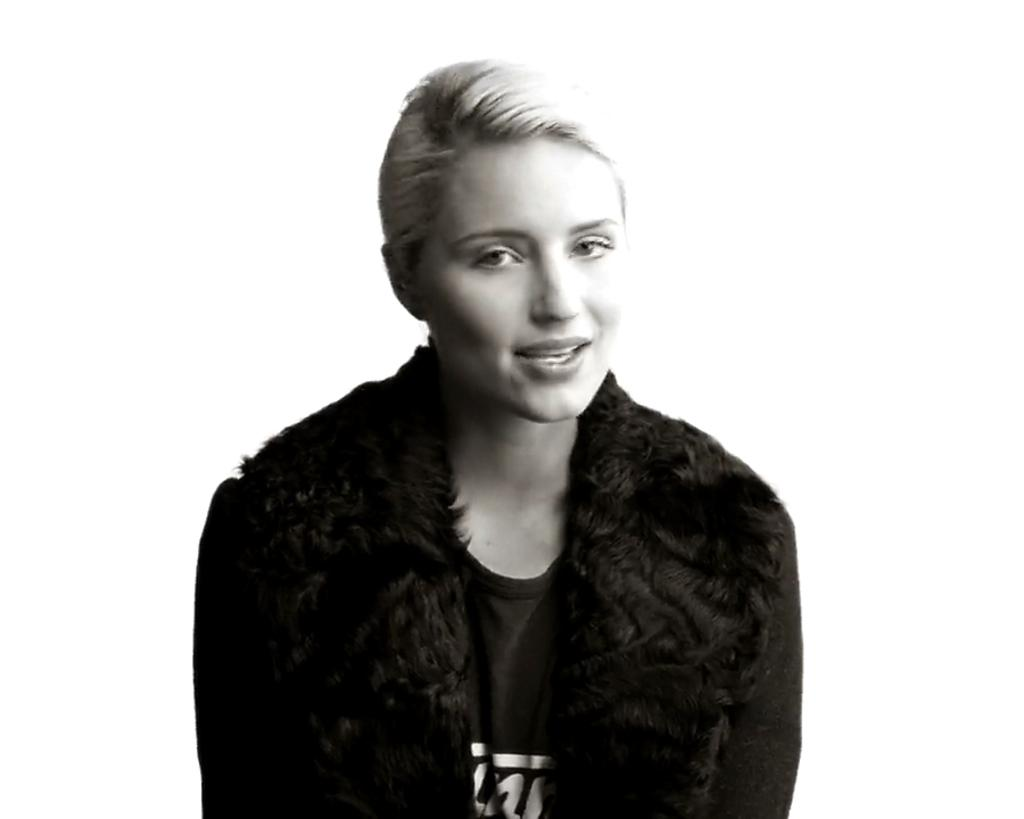What is present in the image? There is a person in the image. Can you describe the person's attire? The person is wearing a black dress. What type of bread can be seen on the person's knee in the image? There is no bread present in the image, nor is there any reference to a knee. 